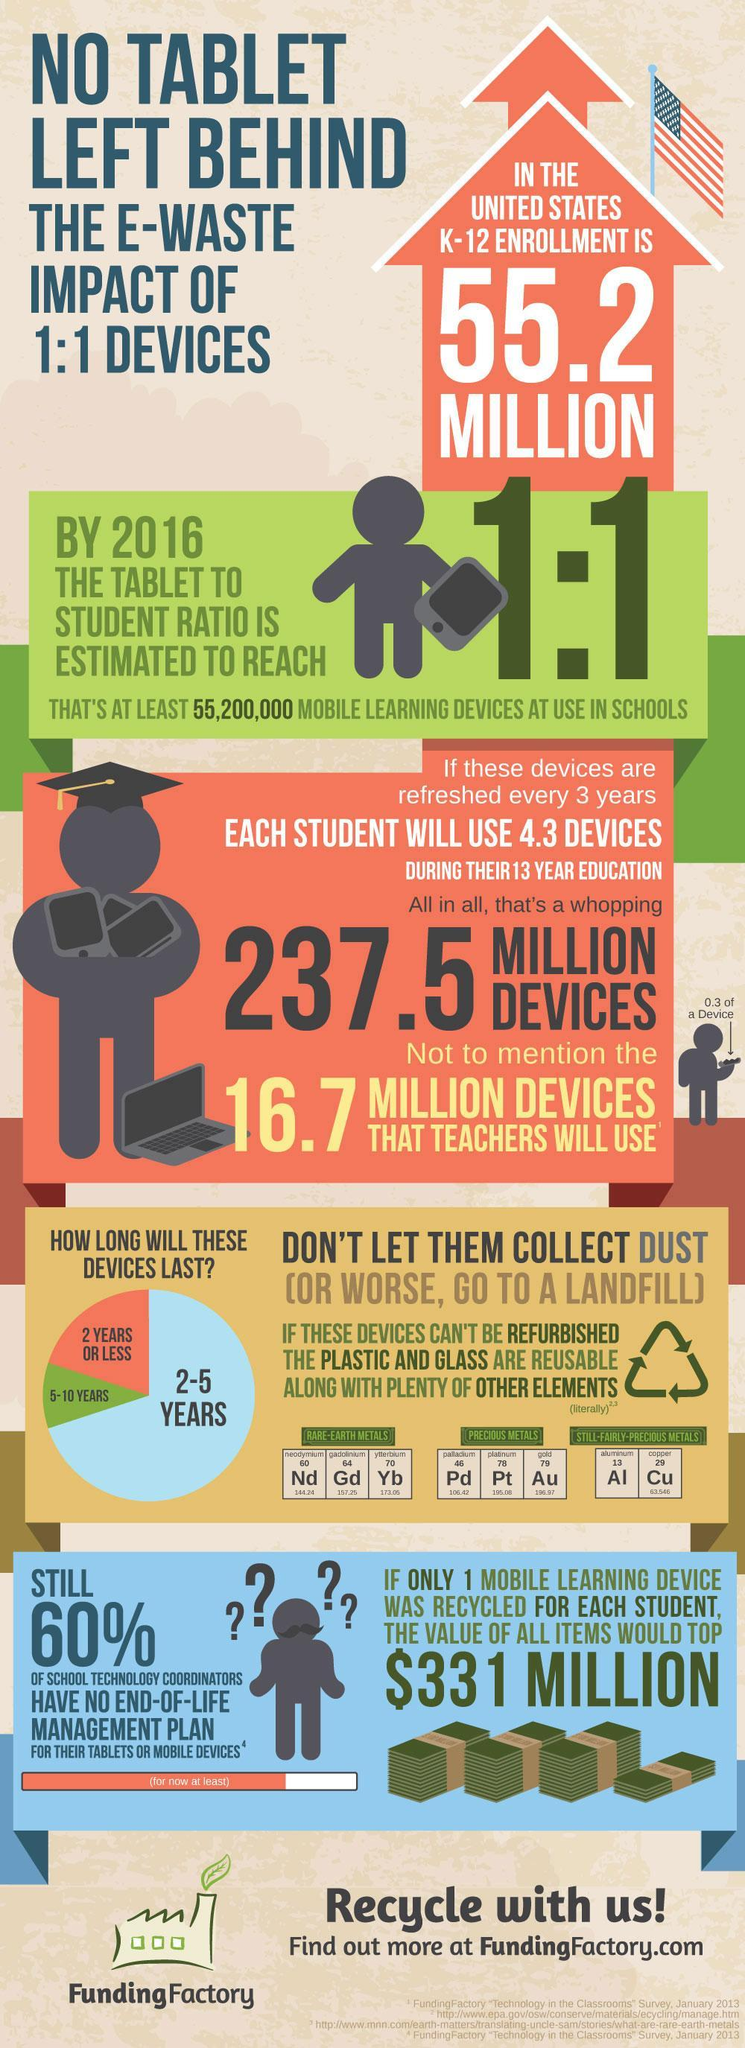What is the total number of devices the students and teachers would use during a 13 year period?
Answer the question with a short phrase. 254.2 million devices What is the atomic mass of Copper? 63.546 What is the life span of most mobile learning devices? 2-5 years What is the atomic number of Aluminium ? 13 What is the chemical symbol of gold? Au 